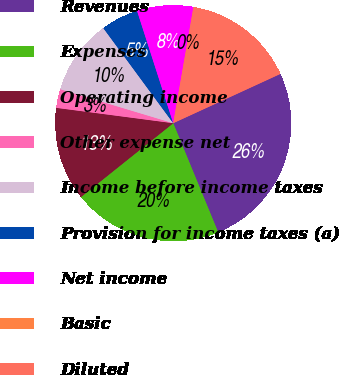Convert chart. <chart><loc_0><loc_0><loc_500><loc_500><pie_chart><fcel>Revenues<fcel>Expenses<fcel>Operating income<fcel>Other expense net<fcel>Income before income taxes<fcel>Provision for income taxes (a)<fcel>Net income<fcel>Basic<fcel>Diluted<nl><fcel>25.64%<fcel>20.48%<fcel>12.82%<fcel>2.57%<fcel>10.26%<fcel>5.13%<fcel>7.7%<fcel>0.01%<fcel>15.39%<nl></chart> 